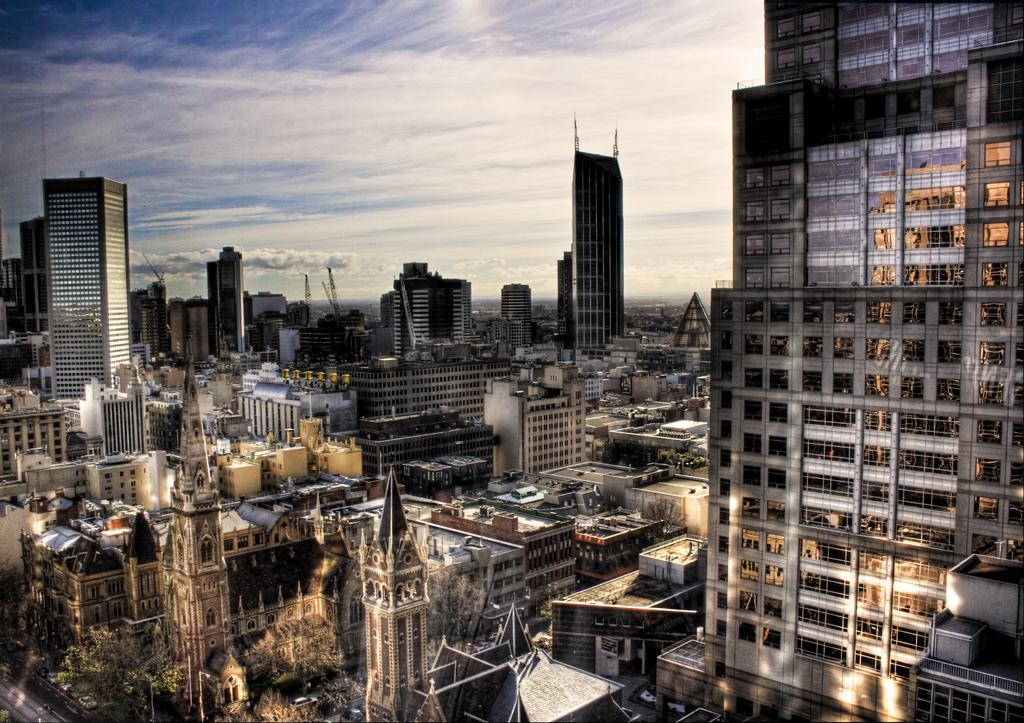What type of view is shown in the image? The image is a top view of a city. What can be seen on the roads in the image? There are vehicles on the roads in the image. What are some features of the cityscape visible in the image? There are lamp posts, trees, buildings, and clouds in the sky in the image. How many sheep can be seen grazing in the image? There are no sheep present in the image; it is a top view of a city with various urban elements. Are there any rabbits visible in the image? There are no rabbits present in the image; it is a top view of a city with various urban elements. 